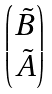Convert formula to latex. <formula><loc_0><loc_0><loc_500><loc_500>\begin{pmatrix} { \tilde { B } } \\ { \tilde { A } } \end{pmatrix}</formula> 